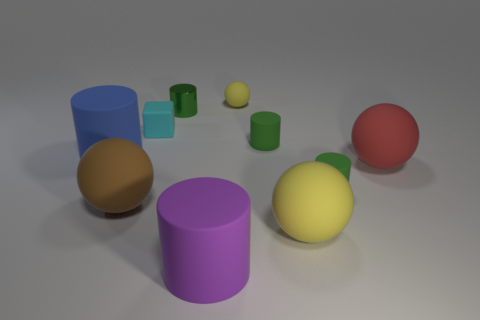Subtract all gray blocks. How many green cylinders are left? 3 Subtract 2 cylinders. How many cylinders are left? 3 Subtract all purple cylinders. How many cylinders are left? 4 Subtract all cyan cylinders. Subtract all yellow balls. How many cylinders are left? 5 Subtract all spheres. How many objects are left? 6 Subtract 0 cyan cylinders. How many objects are left? 10 Subtract all big cylinders. Subtract all shiny things. How many objects are left? 7 Add 8 small green shiny things. How many small green shiny things are left? 9 Add 6 large yellow spheres. How many large yellow spheres exist? 7 